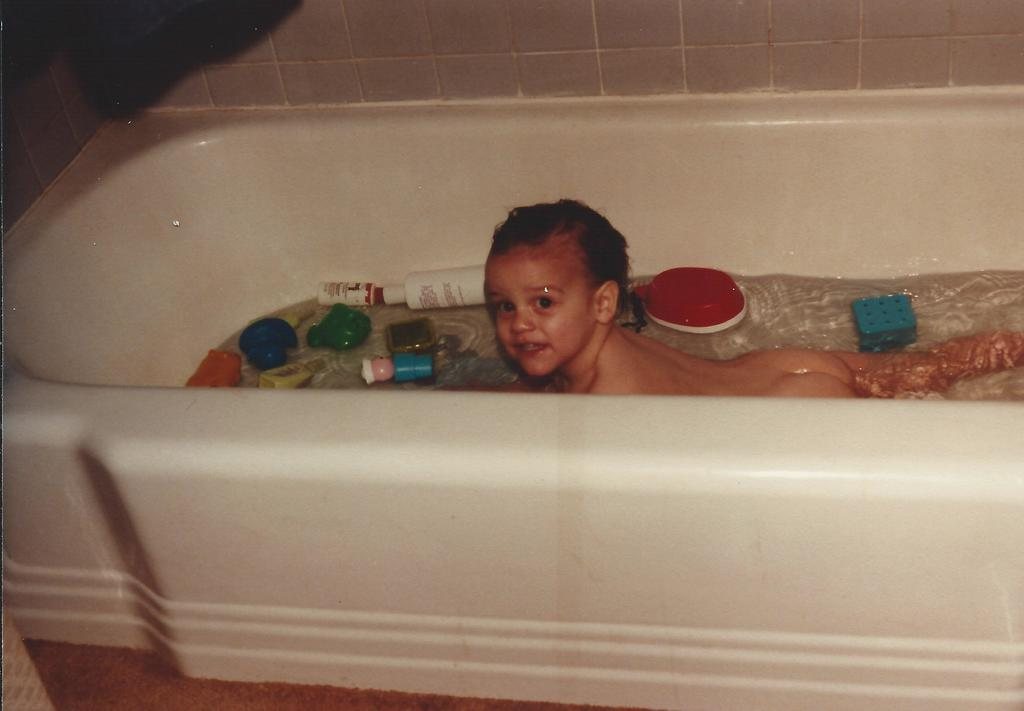What is the main object in the image? There is a bathtub in the image. What is happening in the bathtub? There is a baby in the water. Can you describe any other objects or features in the image? There are a few things visible in the image, including a baby in the water. What is the background of the image like? There is a marble wall in the background, which appears to be black. What type of crime is being committed in the image? There is no crime being committed in the image; it features a baby in a bathtub with a black marble wall in the background. Can you see a snake in the image? There is no snake present in the image. 